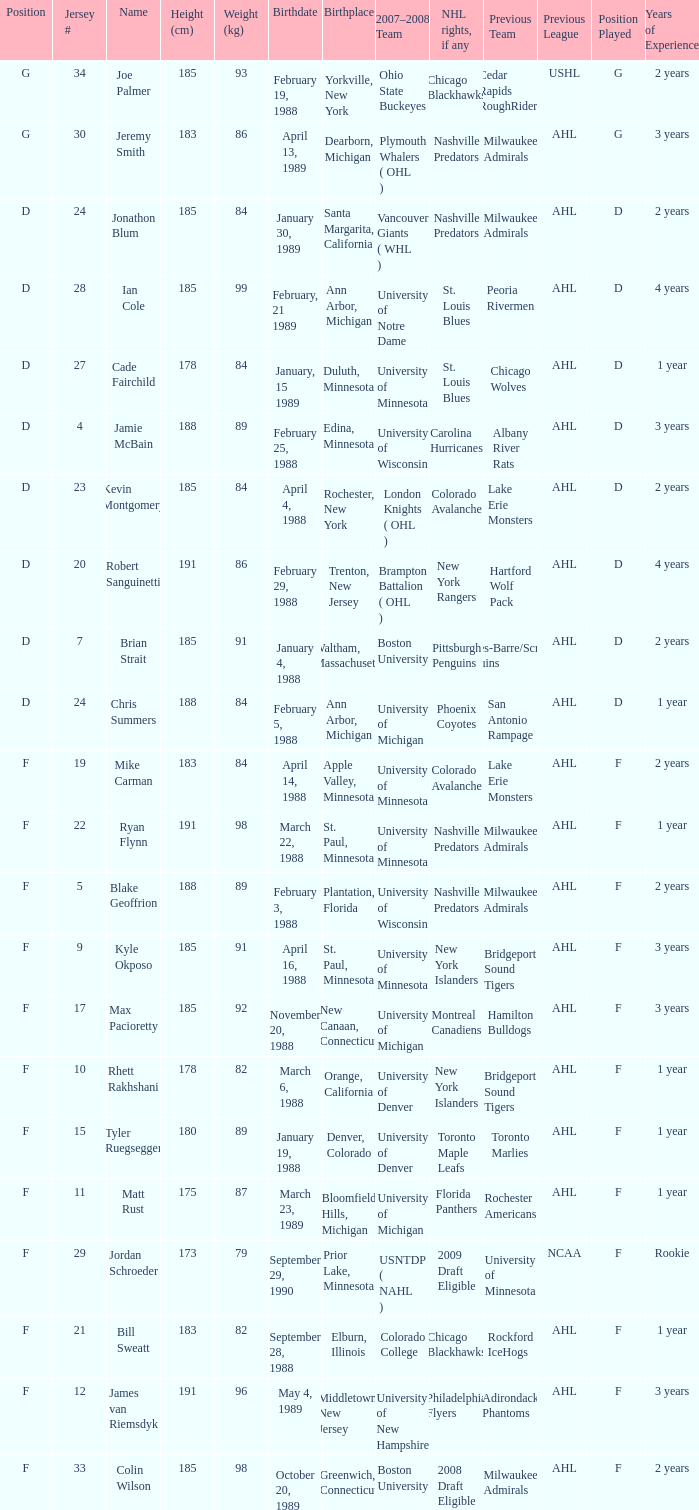Which Weight (kg) has a NHL rights, if any of phoenix coyotes? 1.0. 